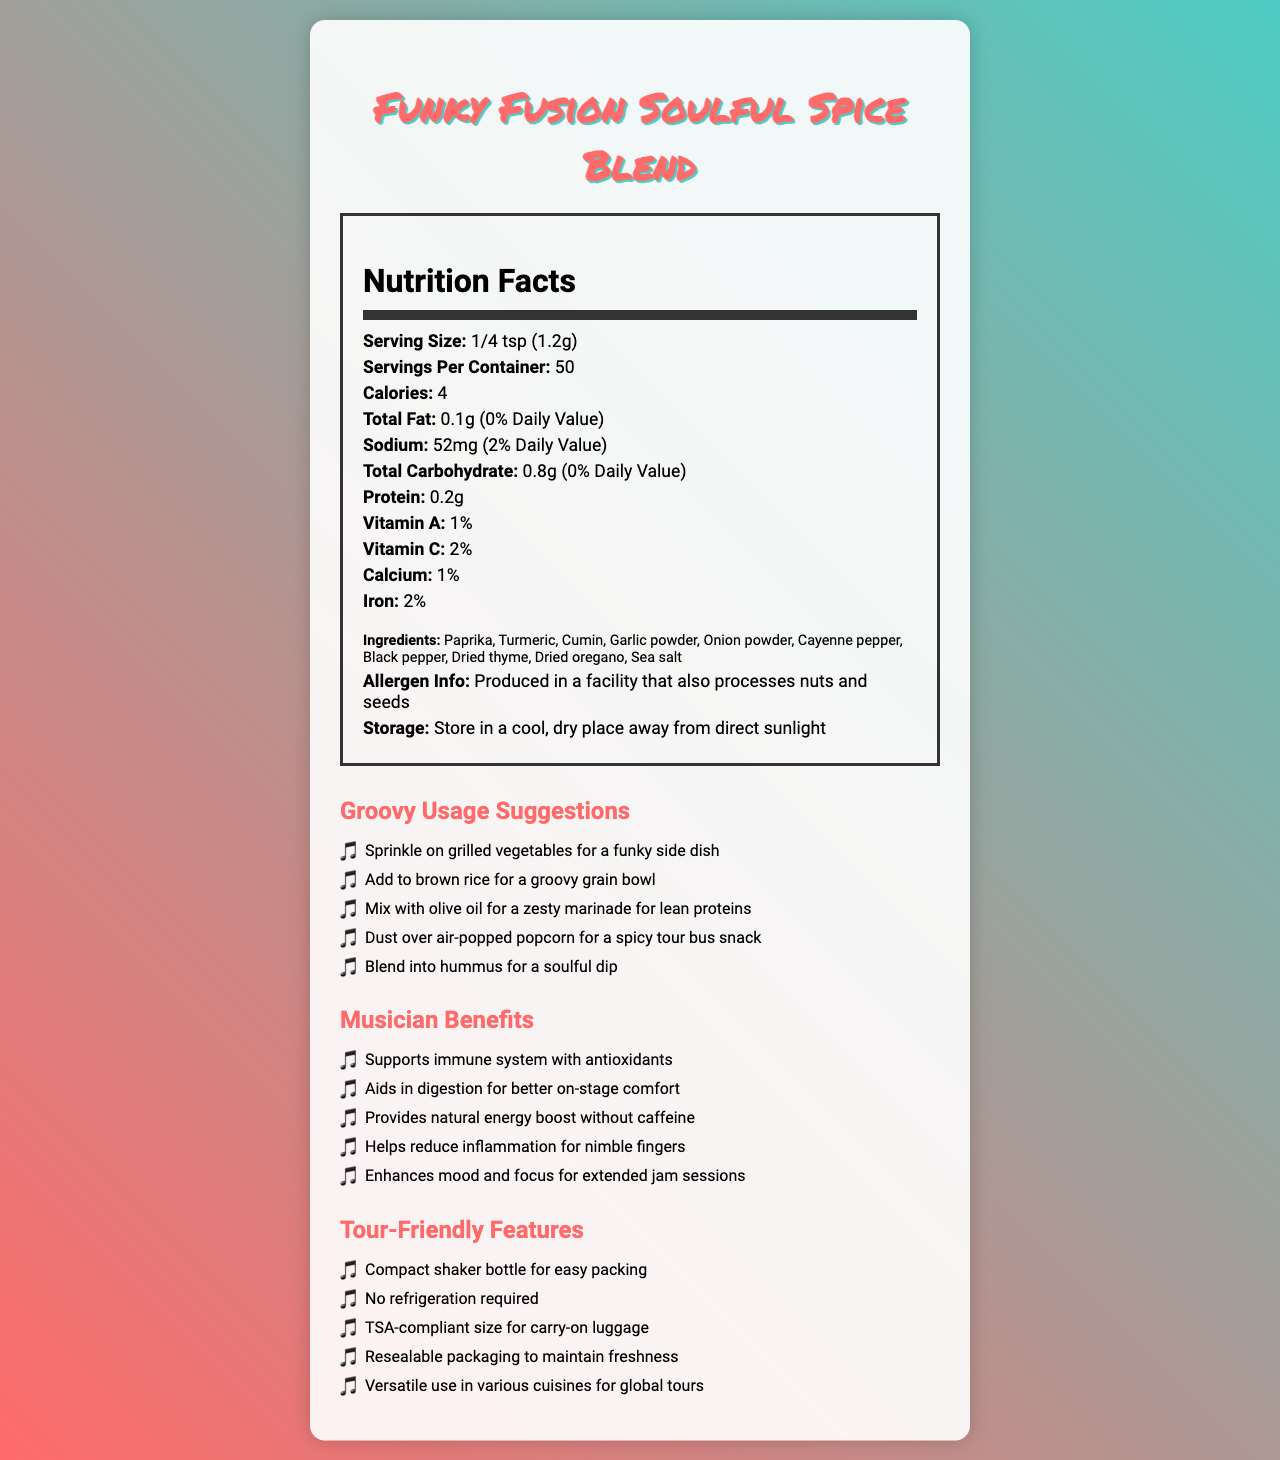what is the serving size? The serving size is clearly mentioned as "1/4 tsp (1.2g)" in the nutrition label section of the document.
Answer: 1/4 tsp (1.2g) how many servings are there per container? The number of servings per container is stated as "50" in the nutrition facts section.
Answer: 50 what is the amount of sodium in one serving? The document specifies that each serving contains 52mg of sodium.
Answer: 52mg which vitamins are present and their percentages? The vitamins listed are Vitamin A and Vitamin C with their respective daily values mentioned as 1% and 2%.
Answer: Vitamin A: 1%, Vitamin C: 2% what are the ingredients in the Soulful Spice Blend? The list of ingredients is provided in the ingredients section of the document.
Answer: Paprika, Turmeric, Cumin, Garlic powder, Onion powder, Cayenne pepper, Black pepper, Dried thyme, Dried oregano, Sea salt is this product processed in a facility that handles allergens? The allergen information states that it is produced in a facility that also processes nuts and seeds, thus handling allergens.
Answer: Yes what are the calories per serving? The document mentions that each serving contains 4 calories.
Answer: 4 which of the following features makes it easy to pack for tours? A. Large packaging B. No refrigeration required C. Needs constant stirring The document mentions that one of the tour-friendly features is "No refrigeration required", making it easy to pack for tours.
Answer: B. No refrigeration required what is one benefit of this spice blend for musicians? A. Enhances mood and focus B. Increases calorie intake C. Promotes weight loss One of the musician benefits listed is "Enhances mood and focus for extended jam sessions".
Answer: A. Enhances mood and focus can this spice blend be used in hummus? One of the usage suggestions is to "Blend into hummus for a soulful dip".
Answer: Yes what should be done to maintain the freshness of the product? The storage instructions indicate that it should be stored in a cool, dry place away from direct sunlight to maintain freshness.
Answer: Store in a cool, dry place away from direct sunlight what is the main idea of this document? The document is comprehensive, describing various aspects of the Funky Fusion Soulful Spice Blend, from nutritional content to practical benefits and usage scenarios, targeting musicians on tour.
Answer: The document provides detailed information about the Funky Fusion Soulful Spice Blend, including its nutrition facts, ingredients, allergen information, storage instructions, usage suggestions, benefits for musicians, and tour-friendly features. how much protein is in one serving? The nutrition label mentions that each serving contains 0.2g of protein.
Answer: 0.2g can this product help in reducing inflammation for musicians? One of the musician benefits explicitly states that it helps reduce inflammation for nimble fingers.
Answer: Yes which ingredient is not mentioned in the ingredients list? A. Paprika B. Ginger C. Sea salt Ginger is not listed as one of the ingredients in the document.
Answer: B. Ginger what are the total carbohydrates in one serving? The document states that each serving contains 0.8g of total carbohydrates.
Answer: 0.8g is this product available in a TSA-compliant size for carry-on luggage? One of the tour-friendly features mentioned is that it is TSA-compliant for carry-on luggage.
Answer: Yes what antioxidant vitamins are found in the spice blend? The document does not specify which vitamins act as antioxidants in the blend.
Answer: Cannot be determined Name two benefits of this spice blend for musicians. Two of the benefits listed are: "Supports immune system with antioxidants" and "Provides natural energy boost without caffeine".
Answer: Supports immune system with antioxidants, Provides natural energy boost without caffeine 